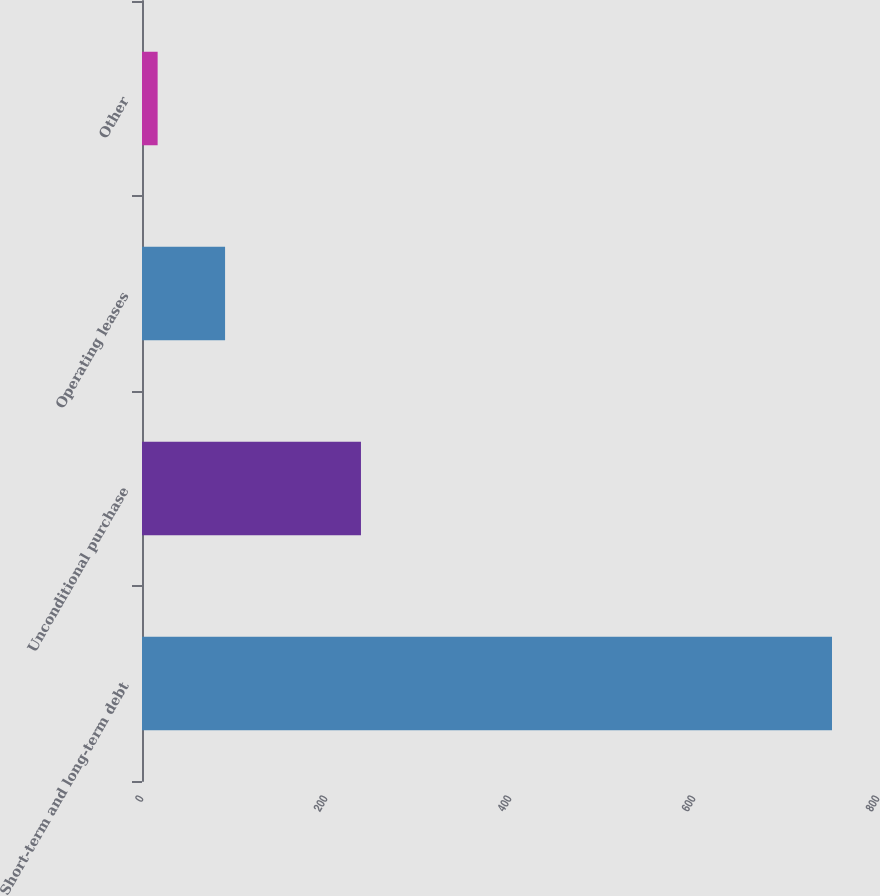Convert chart to OTSL. <chart><loc_0><loc_0><loc_500><loc_500><bar_chart><fcel>Short-term and long-term debt<fcel>Unconditional purchase<fcel>Operating leases<fcel>Other<nl><fcel>750<fcel>238<fcel>90.3<fcel>17<nl></chart> 